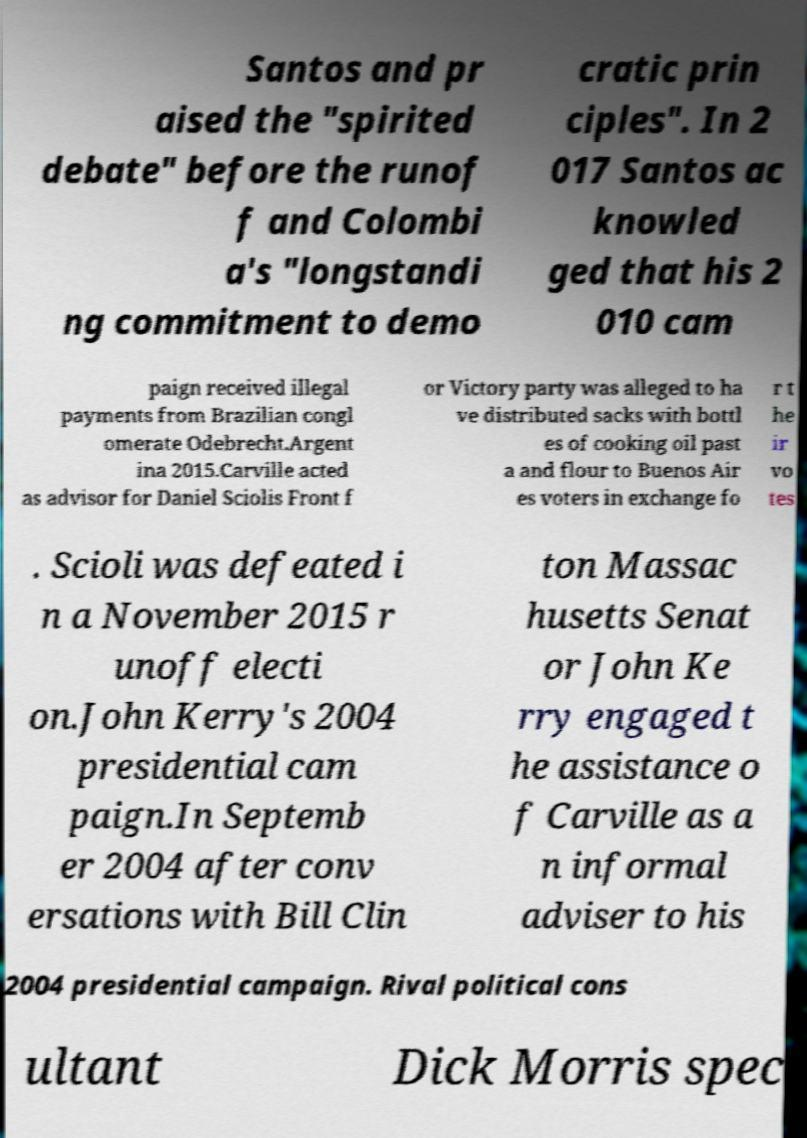Could you extract and type out the text from this image? Santos and pr aised the "spirited debate" before the runof f and Colombi a's "longstandi ng commitment to demo cratic prin ciples". In 2 017 Santos ac knowled ged that his 2 010 cam paign received illegal payments from Brazilian congl omerate Odebrecht.Argent ina 2015.Carville acted as advisor for Daniel Sciolis Front f or Victory party was alleged to ha ve distributed sacks with bottl es of cooking oil past a and flour to Buenos Air es voters in exchange fo r t he ir vo tes . Scioli was defeated i n a November 2015 r unoff electi on.John Kerry's 2004 presidential cam paign.In Septemb er 2004 after conv ersations with Bill Clin ton Massac husetts Senat or John Ke rry engaged t he assistance o f Carville as a n informal adviser to his 2004 presidential campaign. Rival political cons ultant Dick Morris spec 